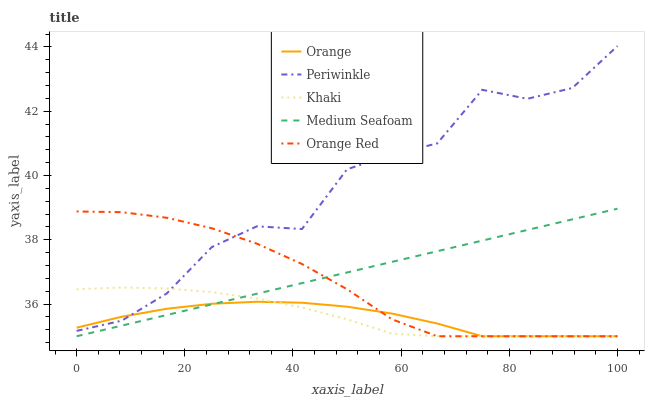Does Orange have the minimum area under the curve?
Answer yes or no. Yes. Does Periwinkle have the maximum area under the curve?
Answer yes or no. Yes. Does Khaki have the minimum area under the curve?
Answer yes or no. No. Does Khaki have the maximum area under the curve?
Answer yes or no. No. Is Medium Seafoam the smoothest?
Answer yes or no. Yes. Is Periwinkle the roughest?
Answer yes or no. Yes. Is Khaki the smoothest?
Answer yes or no. No. Is Khaki the roughest?
Answer yes or no. No. Does Periwinkle have the lowest value?
Answer yes or no. No. Does Periwinkle have the highest value?
Answer yes or no. Yes. Does Khaki have the highest value?
Answer yes or no. No. Is Medium Seafoam less than Periwinkle?
Answer yes or no. Yes. Is Periwinkle greater than Medium Seafoam?
Answer yes or no. Yes. Does Periwinkle intersect Orange Red?
Answer yes or no. Yes. Is Periwinkle less than Orange Red?
Answer yes or no. No. Is Periwinkle greater than Orange Red?
Answer yes or no. No. Does Medium Seafoam intersect Periwinkle?
Answer yes or no. No. 